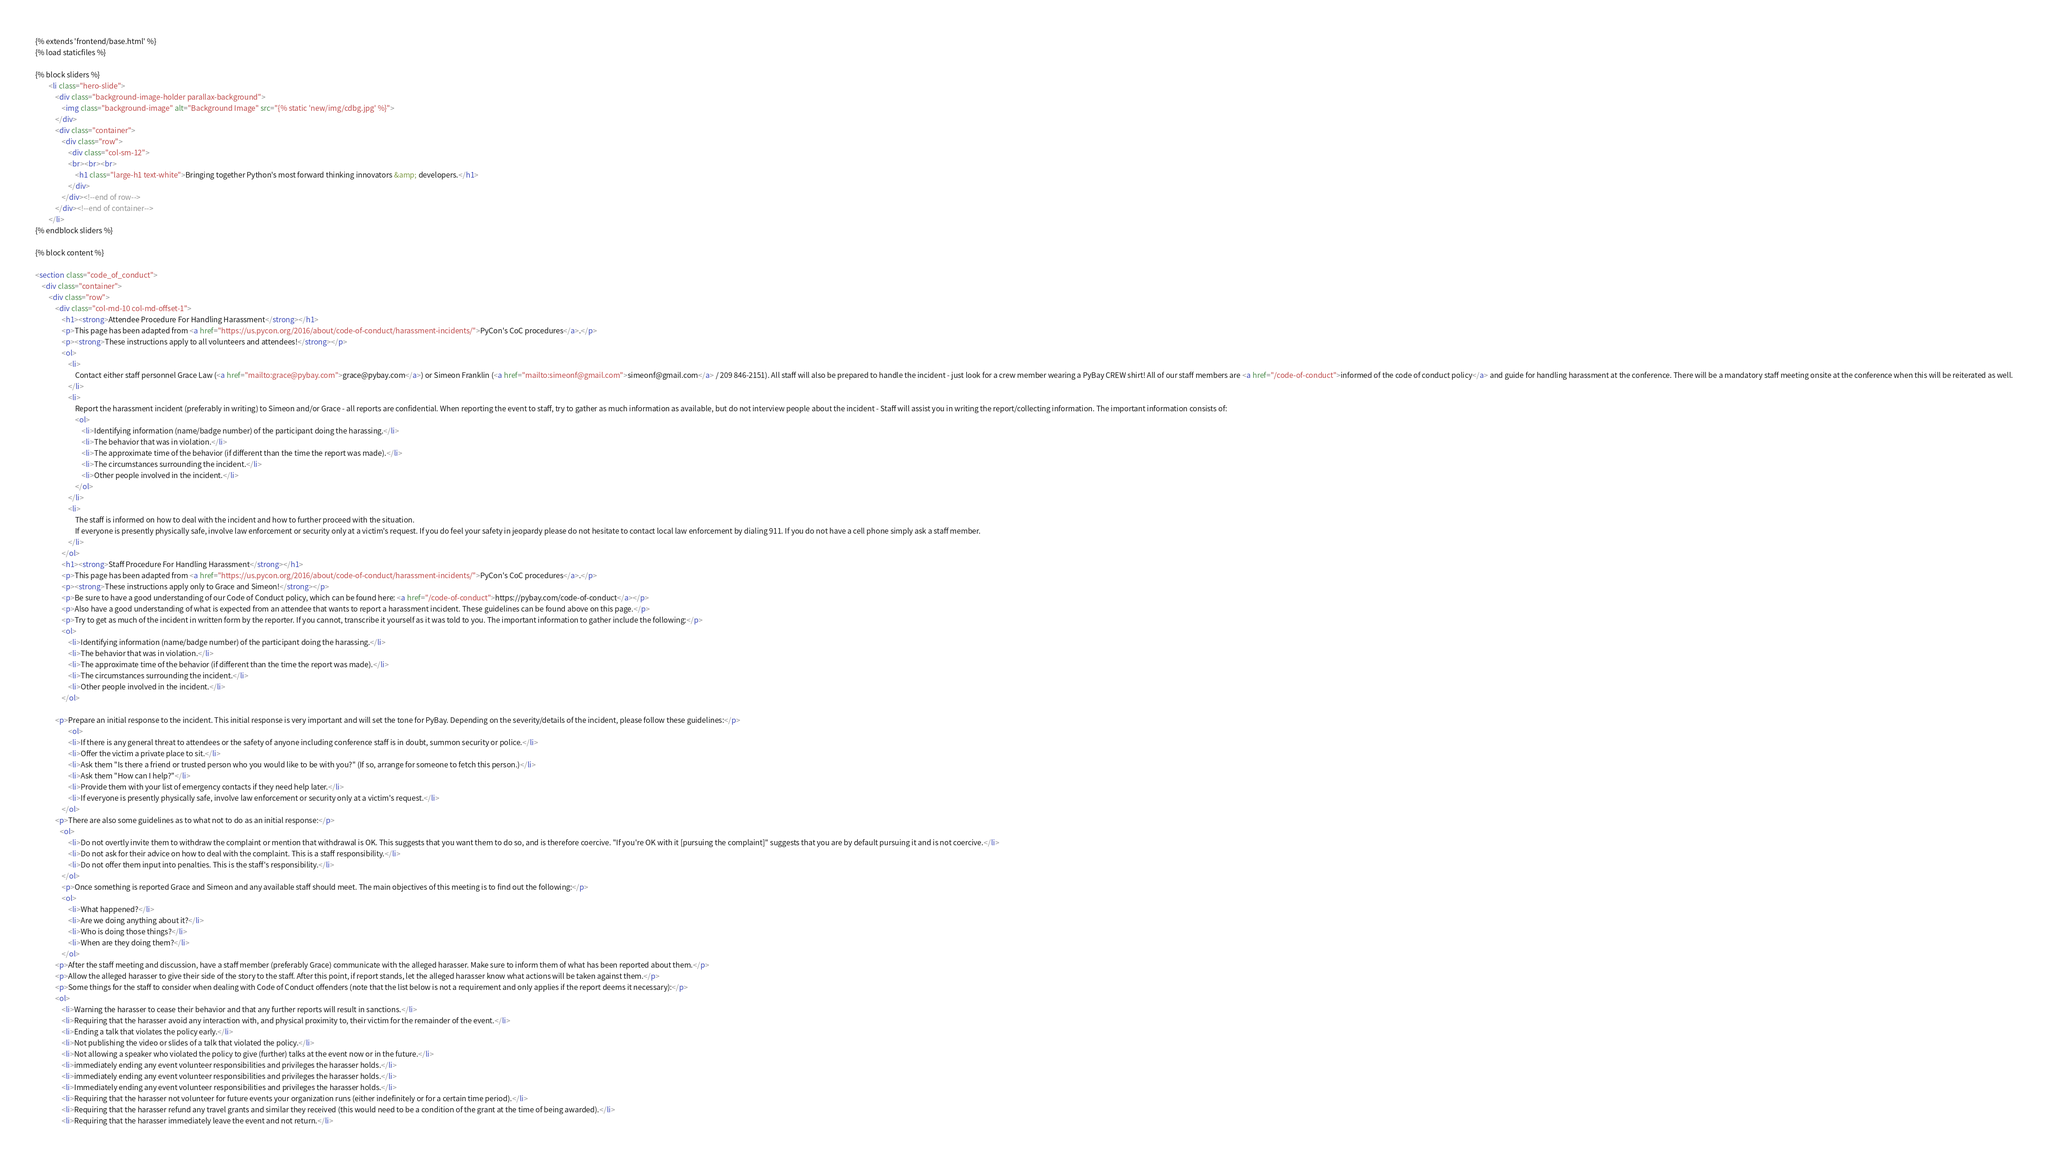<code> <loc_0><loc_0><loc_500><loc_500><_HTML_>{% extends 'frontend/base.html' %}
{% load staticfiles %}

{% block sliders %}
        <li class="hero-slide">
            <div class="background-image-holder parallax-background">
                <img class="background-image" alt="Background Image" src="{% static 'new/img/cdbg.jpg' %}">
            </div>
            <div class="container">
                <div class="row">
                    <div class="col-sm-12">
                    <br><br><br>
                        <h1 class="large-h1 text-white">Bringing together Python's most forward thinking innovators &amp; developers.</h1>
                    </div>
                </div><!--end of row-->
            </div><!--end of container-->
        </li>
{% endblock sliders %}

{% block content %}

<section class="code_of_conduct">
    <div class="container">
        <div class="row">
            <div class="col-md-10 col-md-offset-1">
                <h1><strong>Attendee Procedure For Handling Harassment</strong></h1>
                <p>This page has been adapted from <a href="https://us.pycon.org/2016/about/code-of-conduct/harassment-incidents/">PyCon's CoC procedures</a>.</p>
                <p><strong>These instructions apply to all volunteers and attendees!</strong></p>
                <ol>
                    <li>
                        Contact either staff personnel Grace Law (<a href="mailto:grace@pybay.com">grace@pybay.com</a>) or Simeon Franklin (<a href="mailto:simeonf@gmail.com">simeonf@gmail.com</a> / 209 846-2151). All staff will also be prepared to handle the incident - just look for a crew member wearing a PyBay CREW shirt! All of our staff members are <a href="/code-of-conduct">informed of the code of conduct policy</a> and guide for handling harassment at the conference. There will be a mandatory staff meeting onsite at the conference when this will be reiterated as well.
                    </li>
                    <li>
                        Report the harassment incident (preferably in writing) to Simeon and/or Grace - all reports are confidential. When reporting the event to staff, try to gather as much information as available, but do not interview people about the incident - Staff will assist you in writing the report/collecting information. The important information consists of:
                        <ol>
                            <li>Identifying information (name/badge number) of the participant doing the harassing.</li>
                            <li>The behavior that was in violation.</li>
                            <li>The approximate time of the behavior (if different than the time the report was made).</li>
                            <li>The circumstances surrounding the incident.</li>
                            <li>Other people involved in the incident.</li>
                        </ol>
                    </li>
                    <li>
                        The staff is informed on how to deal with the incident and how to further proceed with the situation.
                        If everyone is presently physically safe, involve law enforcement or security only at a victim's request. If you do feel your safety in jeopardy please do not hesitate to contact local law enforcement by dialing 911. If you do not have a cell phone simply ask a staff member.
                    </li>
                </ol>
                <h1><strong>Staff Procedure For Handling Harassment</strong></h1>
                <p>This page has been adapted from <a href="https://us.pycon.org/2016/about/code-of-conduct/harassment-incidents/">PyCon's CoC procedures</a>.</p>
                <p><strong>These instructions apply only to Grace and Simeon!</strong></p>
                <p>Be sure to have a good understanding of our Code of Conduct policy, which can be found here: <a href="/code-of-conduct">https://pybay.com/code-of-conduct</a></p>
                <p>Also have a good understanding of what is expected from an attendee that wants to report a harassment incident. These guidelines can be found above on this page.</p>
                <p>Try to get as much of the incident in written form by the reporter. If you cannot, transcribe it yourself as it was told to you. The important information to gather include the following:</p>
                <ol>
                    <li>Identifying information (name/badge number) of the participant doing the harassing.</li>
                    <li>The behavior that was in violation.</li>
                    <li>The approximate time of the behavior (if different than the time the report was made).</li>
                    <li>The circumstances surrounding the incident.</li>
                    <li>Other people involved in the incident.</li>
                </ol>

            <p>Prepare an initial response to the incident. This initial response is very important and will set the tone for PyBay. Depending on the severity/details of the incident, please follow these guidelines:</p>
                    <ol>
                    <li>If there is any general threat to attendees or the safety of anyone including conference staff is in doubt, summon security or police.</li>
                    <li>Offer the victim a private place to sit.</li>
                    <li>Ask them "Is there a friend or trusted person who you would like to be with you?" (If so, arrange for someone to fetch this person.)</li>
                    <li>Ask them "How can I help?"</li>
                    <li>Provide them with your list of emergency contacts if they need help later.</li>
                    <li>If everyone is presently physically safe, involve law enforcement or security only at a victim's request.</li>
                </ol>
            <p>There are also some guidelines as to what not to do as an initial response:</p>
               <ol>
                    <li>Do not overtly invite them to withdraw the complaint or mention that withdrawal is OK. This suggests that you want them to do so, and is therefore coercive. "If you're OK with it [pursuing the complaint]" suggests that you are by default pursuing it and is not coercive.</li>
                    <li>Do not ask for their advice on how to deal with the complaint. This is a staff responsibility.</li>
                    <li>Do not offer them input into penalties. This is the staff's responsibility.</li>
                </ol>
                <p>Once something is reported Grace and Simeon and any available staff should meet. The main objectives of this meeting is to find out the following:</p>
                <ol>
                    <li>What happened?</li>
                    <li>Are we doing anything about it?</li>
                    <li>Who is doing those things?</li>
                    <li>When are they doing them?</li>
                </ol>
            <p>After the staff meeting and discussion, have a staff member (preferably Grace) communicate with the alleged harasser. Make sure to inform them of what has been reported about them.</p>
            <p>Allow the alleged harasser to give their side of the story to the staff. After this point, if report stands, let the alleged harasser know what actions will be taken against them.</p>
            <p>Some things for the staff to consider when dealing with Code of Conduct offenders (note that the list below is not a requirement and only applies if the report deems it necessary):</p>
            <ol>
                <li>Warning the harasser to cease their behavior and that any further reports will result in sanctions.</li>
                <li>Requiring that the harasser avoid any interaction with, and physical proximity to, their victim for the remainder of the event.</li>
                <li>Ending a talk that violates the policy early.</li>
                <li>Not publishing the video or slides of a talk that violated the policy.</li>
                <li>Not allowing a speaker who violated the policy to give (further) talks at the event now or in the future.</li>
                <li>immediately ending any event volunteer responsibilities and privileges the harasser holds.</li>
                <li>immediately ending any event volunteer responsibilities and privileges the harasser holds.</li>
                <li>Immediately ending any event volunteer responsibilities and privileges the harasser holds.</li>
                <li>Requiring that the harasser not volunteer for future events your organization runs (either indefinitely or for a certain time period).</li>
                <li>Requiring that the harasser refund any travel grants and similar they received (this would need to be a condition of the grant at the time of being awarded).</li>
                <li>Requiring that the harasser immediately leave the event and not return.</li></code> 